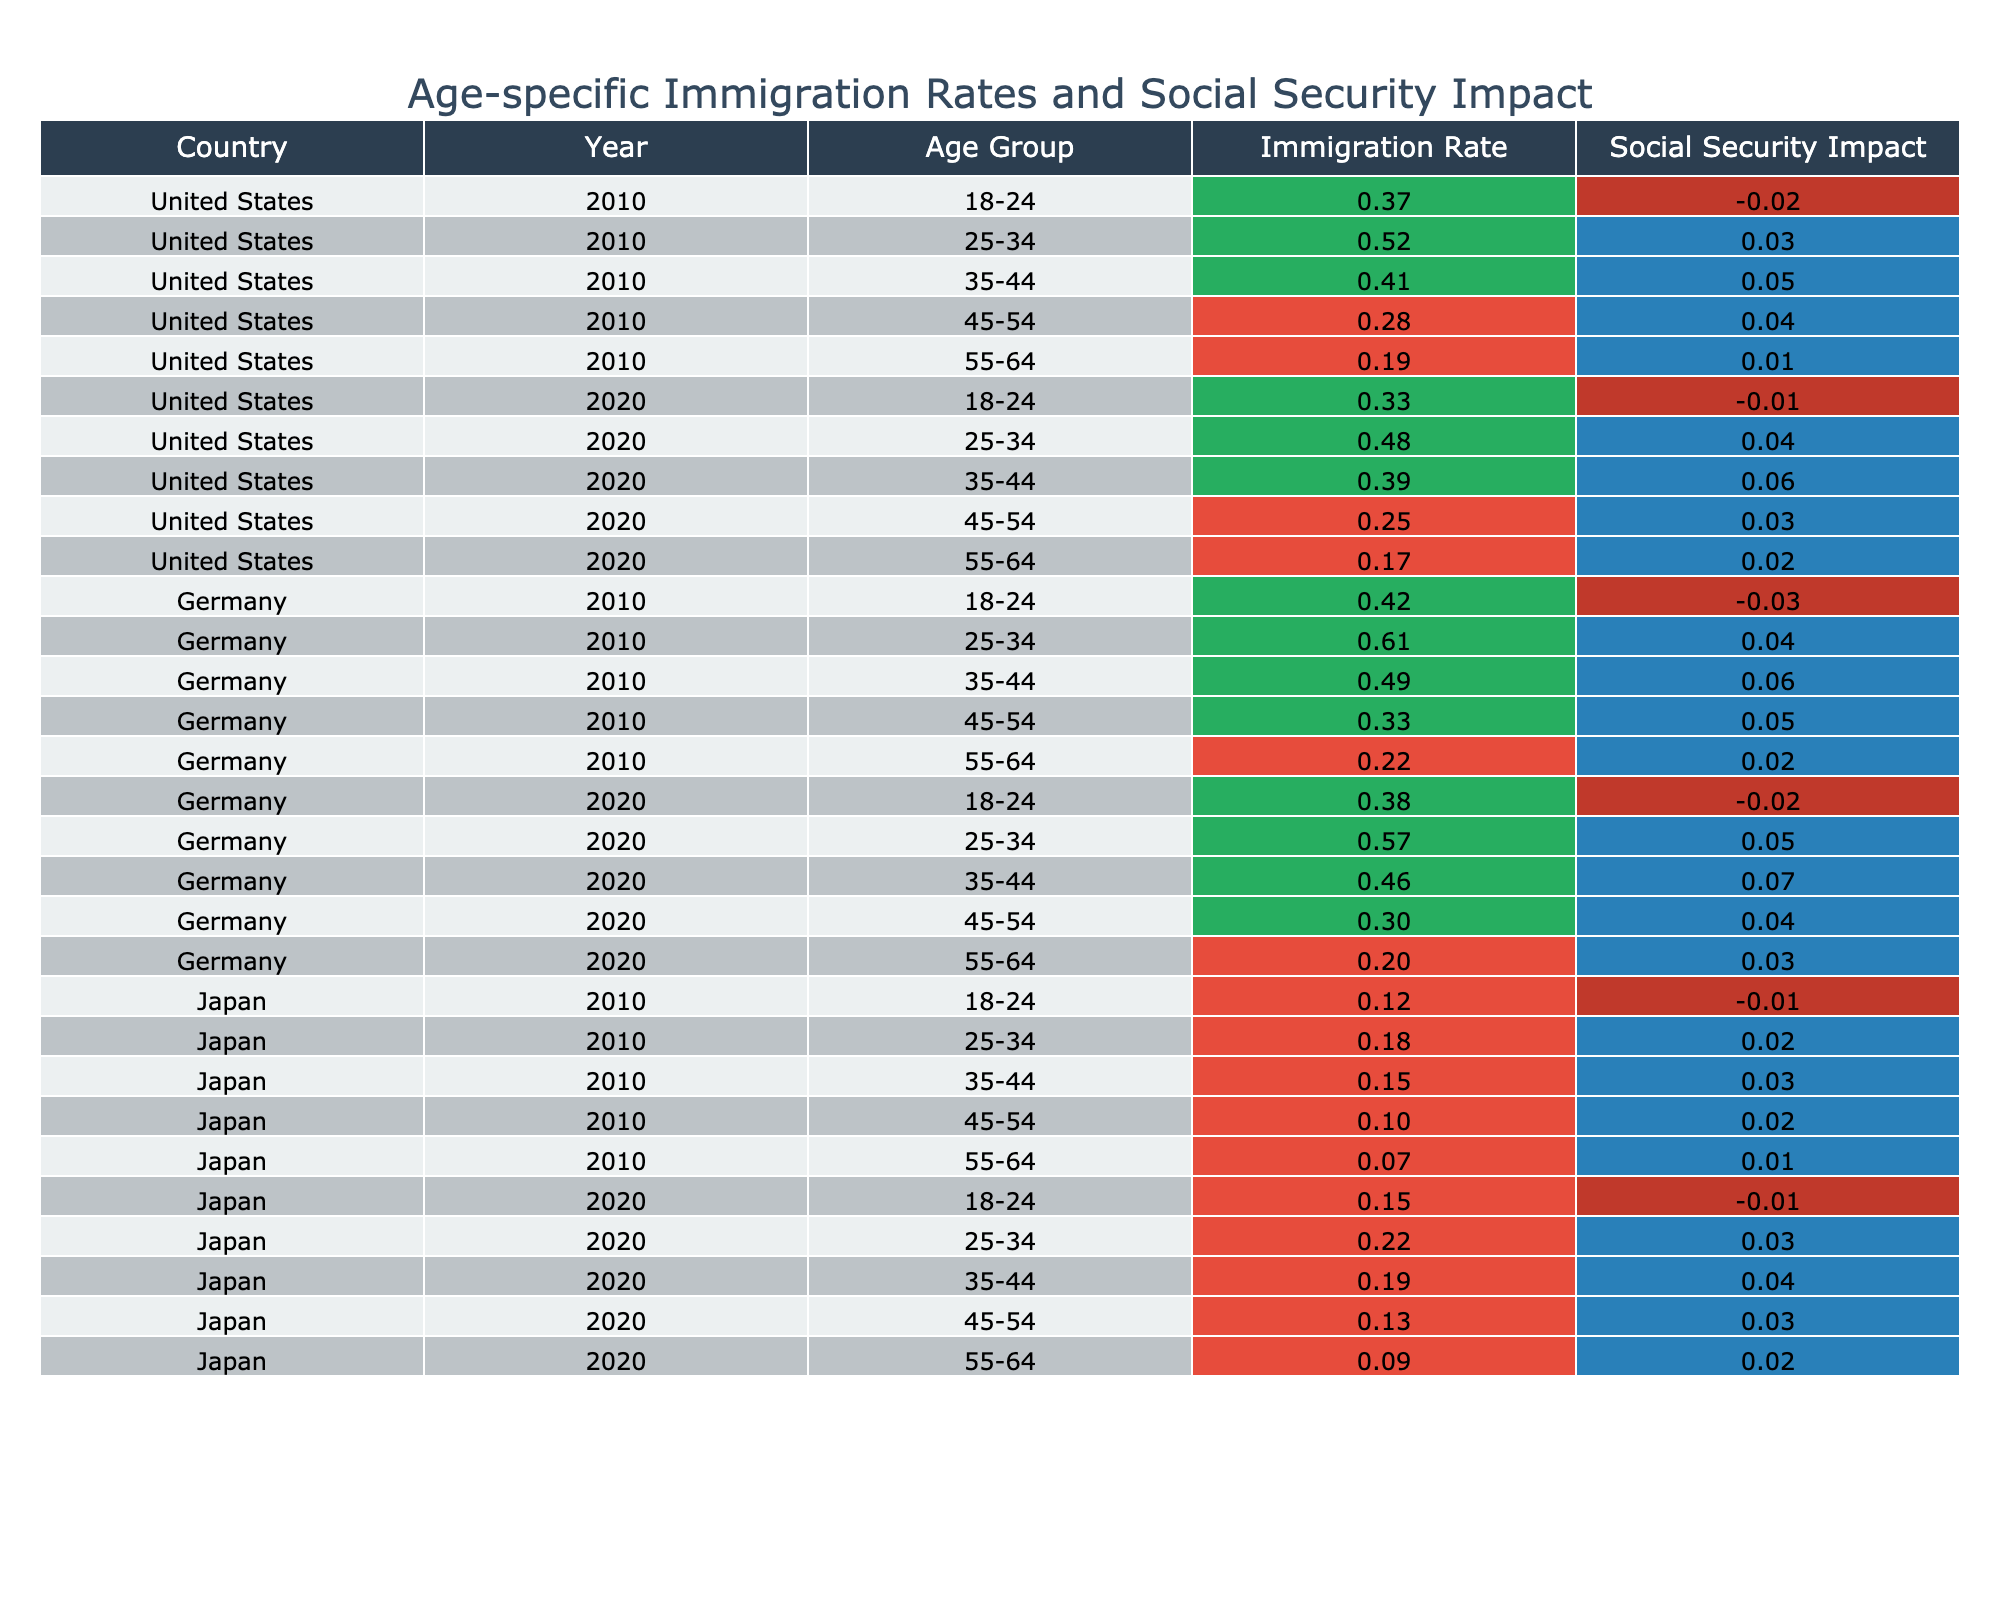What is the immigration rate for the age group 25-34 in Germany in 2020? Looking at the table, find the row for Germany in 2020 and locate the age group 25-34. The immigration rate for this group is listed as 0.57.
Answer: 0.57 What is the social security impact for the age group 45-54 in the United States in 2010? Referring to the table, the row for the United States in 2010 shows that the social security impact for the age group 45-54 is 0.04.
Answer: 0.04 Which country had the highest immigration rate for the age group 35-44 in 2010? In the table, compare the immigration rates for the age group 35-44 in 2010 across the countries: United States (0.41), Germany (0.49), and Japan (0.15). Germany has the highest rate at 0.49.
Answer: Germany What is the average immigration rate for the age group 18-24 across all countries in 2020? First, locate the immigration rates for the age group 18-24 in 2020 for each country: United States (0.33), Germany (0.38), and Japan (0.15). Sum these values: 0.33 + 0.38 + 0.15 = 0.86. There are 3 data points, so divide by 3: 0.86 / 3 = 0.287.
Answer: 0.287 Did the social security impact for the age group 55-64 in Germany improve from 2010 to 2020? Check the social security impacts for Germany in both years: in 2010, it's 0.02 and in 2020, it's 0.03. Since 0.03 is greater than 0.02, the impact improved.
Answer: Yes What is the difference in immigration rates for the age group 25-34 between the years 2010 and 2020 in the United States? Find the immigration rates for the United States in 25-34 for both years: 2010 (0.52) and 2020 (0.48). Now calculate the difference: 0.52 - 0.48 = 0.04.
Answer: 0.04 Which age group in Japan showed the smallest immigration rate in 2020? Look at the rows for Japan in 2020 and note the immigration rates: 18-24 (0.15), 25-34 (0.22), 35-44 (0.19), 45-54 (0.13), and 55-64 (0.09). The smallest rate is for the age group 55-64 at 0.09.
Answer: 55-64 What is the total social security impact for the age group 35-44 across all countries in 2010? Check the social security impacts for the age group 35-44 in 2010 for each country: United States (0.05), Germany (0.06), and Japan (0.03). Sum them: 0.05 + 0.06 + 0.03 = 0.14.
Answer: 0.14 Is the immigration rate for the age group 45-54 in Japan higher in 2020 than in 2010? The immigration rates for Japan's age group 45-54 are 0.10 in 2010 and 0.13 in 2020. Since 0.13 is greater than 0.10, the statement is true.
Answer: Yes Which country had the lowest social security impact for the age group 18-24 in 2010? Looking at the table, for the age group 18-24 in 2010, the impacts are: United States (-0.02), Germany (-0.03), and Japan (-0.01). The lowest impact is for Germany at -0.03.
Answer: Germany 